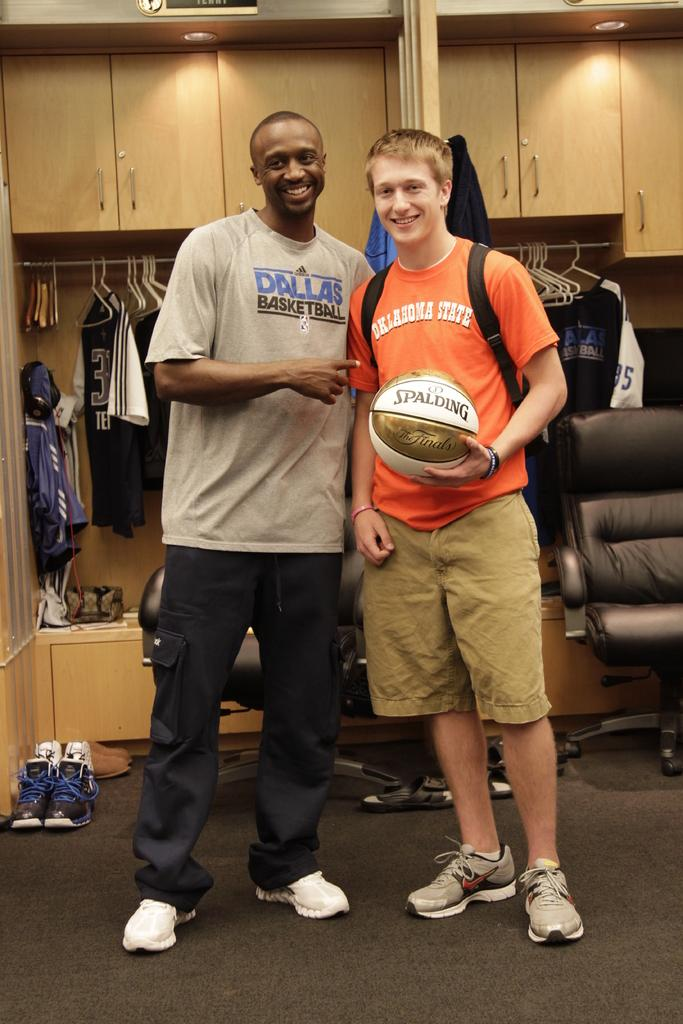<image>
Create a compact narrative representing the image presented. Two men side by side with the word Dallas Basketball and Oklahoma State on their jersey. 